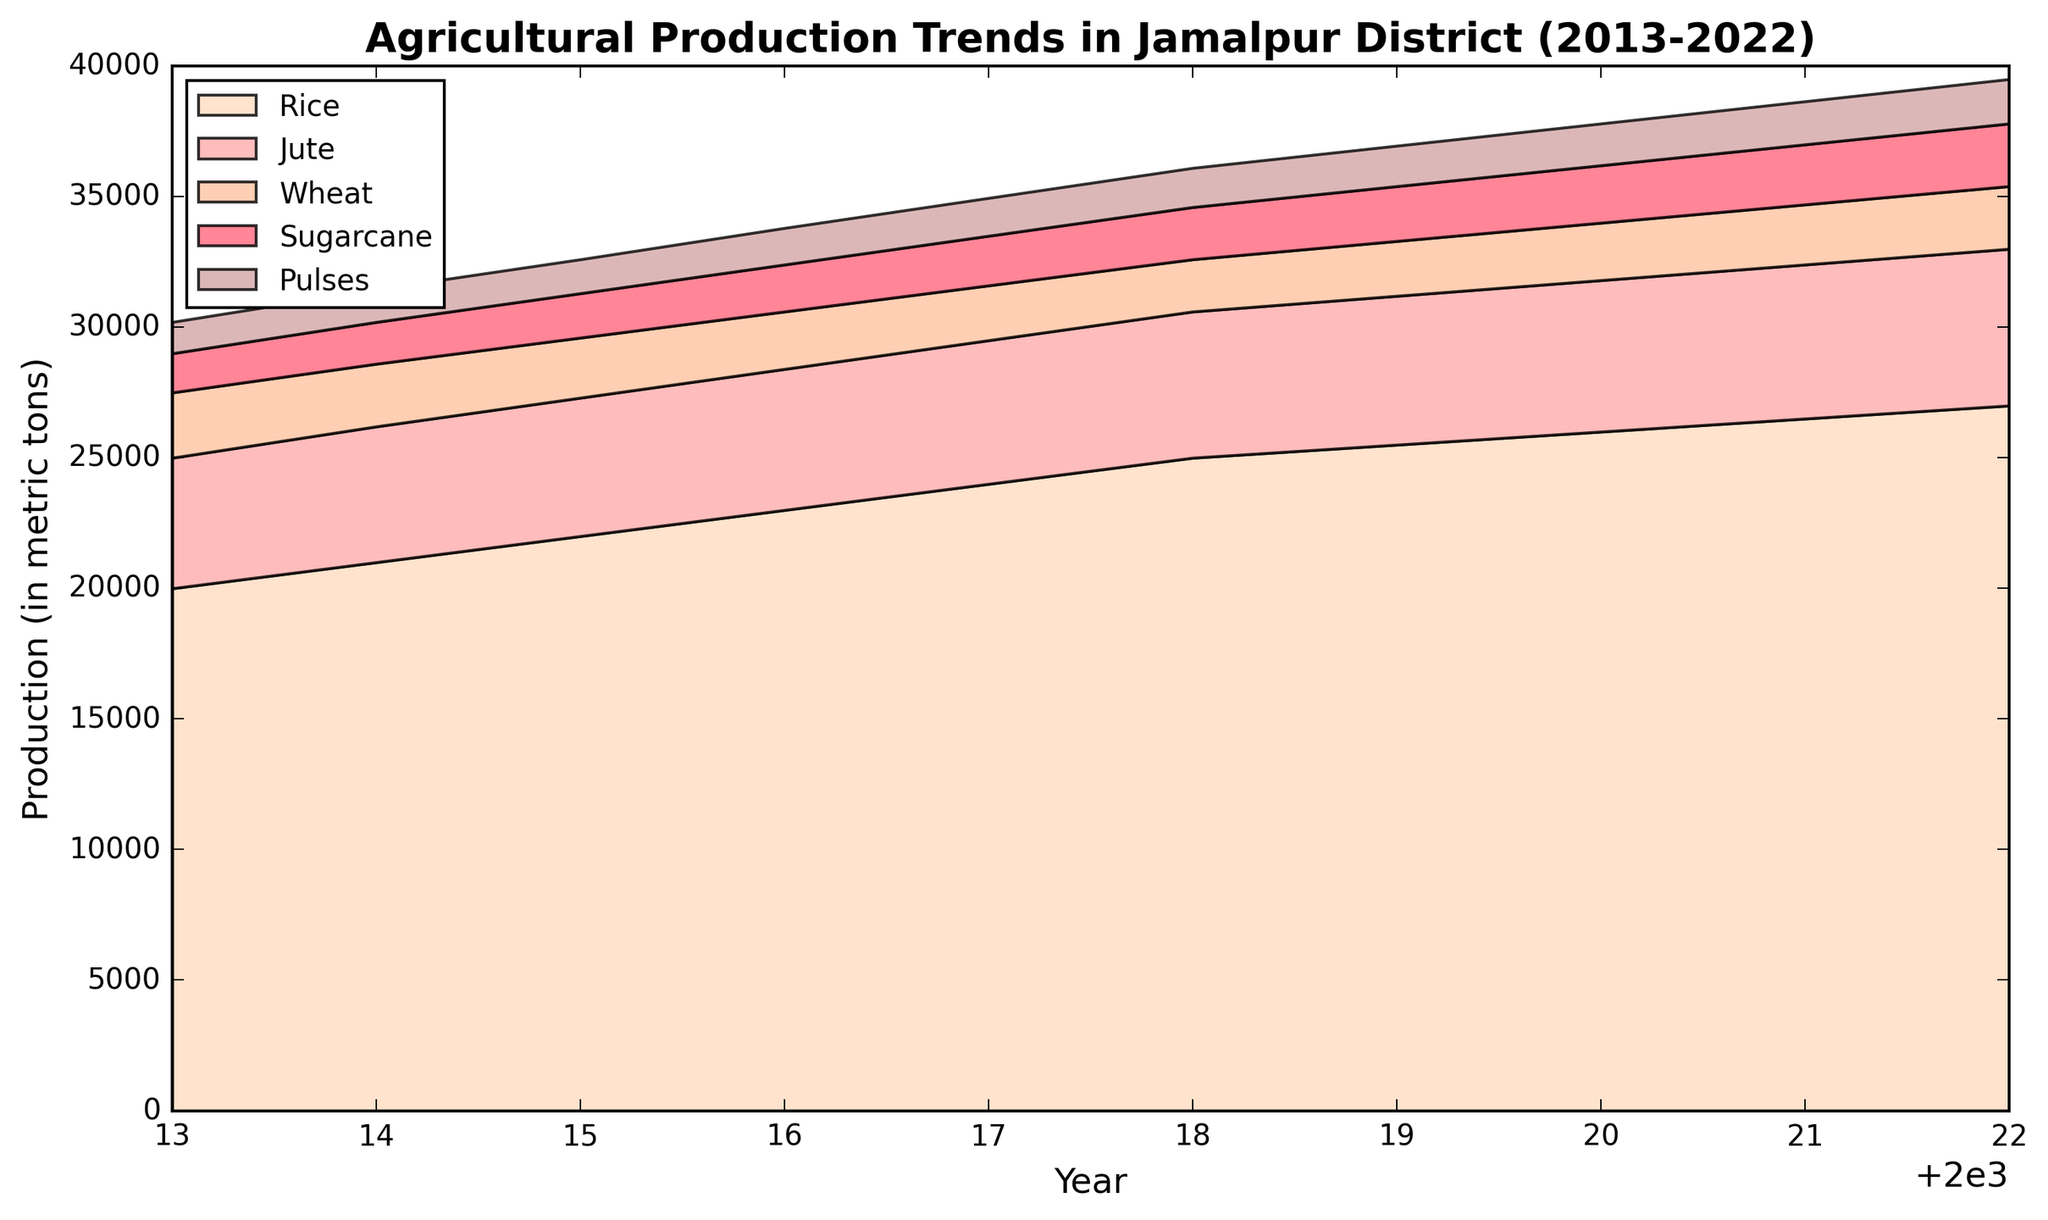Which crop showed the highest production increase from 2013 to 2022? To determine the crop with the highest production increase, subtract the 2013 production value from the 2022 production value for each crop, and compare the results. Rice increased by 7000, Jute by 1000, Wheat by -100, Sugarcane by 900, and Pulses by 500. Rice shows the highest increase.
Answer: Rice Did the production of any crop decrease over the decade? Examine the production values for each crop in 2013 and 2022. If the 2022 value is lower, the crop decreased. Wheat decreased from 2500 to 2400.
Answer: Wheat In which year did Sugarcane production equal Pulses production? To find the year when production values are equal, compare Sugarcane and Pulses values across all years. In 2018, both Sugarcane and Pulses had a production of 2000.
Answer: 2018 How did the overall production trend of Jute change over the decade? Look at the Jute production values from 2013 to 2022. The values steadily increased from 5000 to 6000, indicating a positive trend.
Answer: Increased Which crop showed the least amount of production increase from 2013 to 2022? Calculate the production increase from 2013 to 2022 for each crop. Jute increased by 1000 metric tons, which is the smallest increase compared to other crops.
Answer: Jute What is the production difference between Rice and Wheat in 2022? Subtract Wheat production from Rice production in 2022. Rice had 27000 and Wheat had 2400, so the difference is 27000 - 2400.
Answer: 24600 Compare the production of Rice in 2013 and 2022. By how much did it increase? Subtract the production value of 2013 (20000) from the production value of 2022 (27000). The increase is 27000 - 20000.
Answer: 7000 During which year did Wheat production show a sharp increase? Examine the yearly changes in Wheat production values. The most noticeable increase is from 2020 to 2021, where it increased from 2200 to 2300.
Answer: 2021 Which crop had the second highest production in 2016? Look at the 2016 production values for each crop. The highest production was by Rice (23000), followed by Jute (5400).
Answer: Jute Estimate the average yearly production of Pulses over the decade. Sum the Pulses production values over the ten years and divide by 10. The total is (1200+1250+1300+1400+1450+1500+1550+1600+1650+1700)=14600. The average is 1460 metric tons.
Answer: 1460 